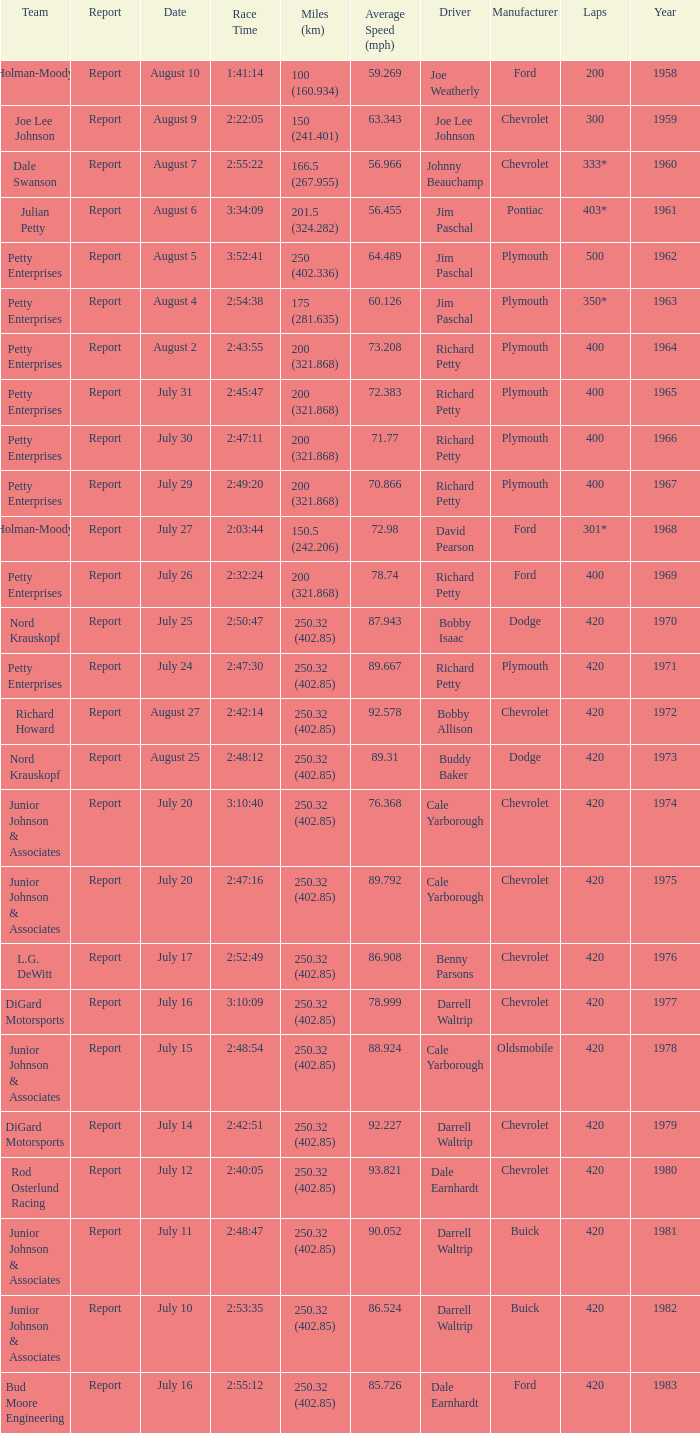How many miles were driven in the race where the winner finished in 2:47:11? 200 (321.868). 